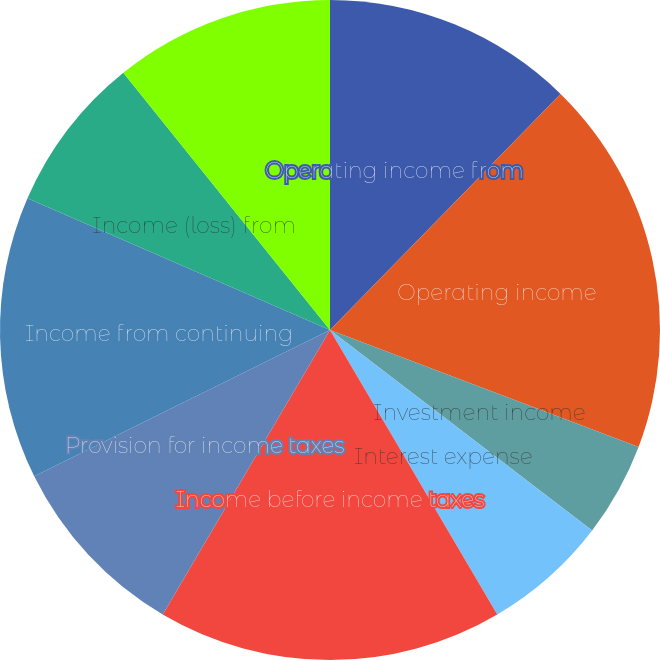Convert chart to OTSL. <chart><loc_0><loc_0><loc_500><loc_500><pie_chart><fcel>Operating income from<fcel>Operating income<fcel>Investment income<fcel>Interest expense<fcel>Income before income taxes<fcel>Provision for income taxes<fcel>Income from continuing<fcel>Income (loss) from<fcel>Net income<nl><fcel>12.31%<fcel>18.46%<fcel>4.62%<fcel>6.15%<fcel>16.92%<fcel>9.23%<fcel>13.85%<fcel>7.69%<fcel>10.77%<nl></chart> 